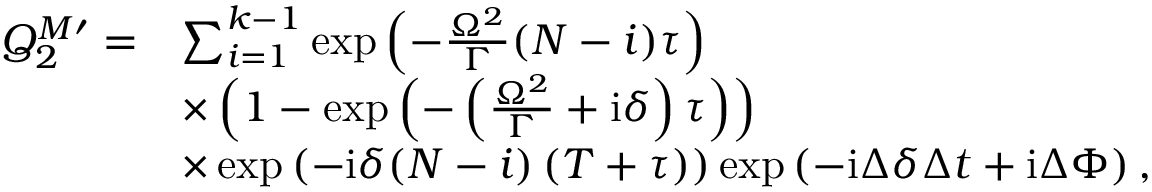Convert formula to latex. <formula><loc_0><loc_0><loc_500><loc_500>\begin{array} { r l } { Q _ { 2 } ^ { M \prime } = } & { \sum _ { i = 1 } ^ { k - 1 } \exp \left ( - \frac { \Omega ^ { 2 } } { \Gamma } ( N - i ) \tau \right ) } \\ & { \times \left ( 1 - \exp \left ( - \left ( \frac { \Omega ^ { 2 } } { \Gamma } + i \delta \right ) \tau \right ) \right ) } \\ & { \times \exp \left ( - i \delta ( N - i ) \left ( T + \tau \right ) \right ) \exp \left ( - i \Delta \delta \Delta t + i \Delta \Phi \right ) , } \end{array}</formula> 